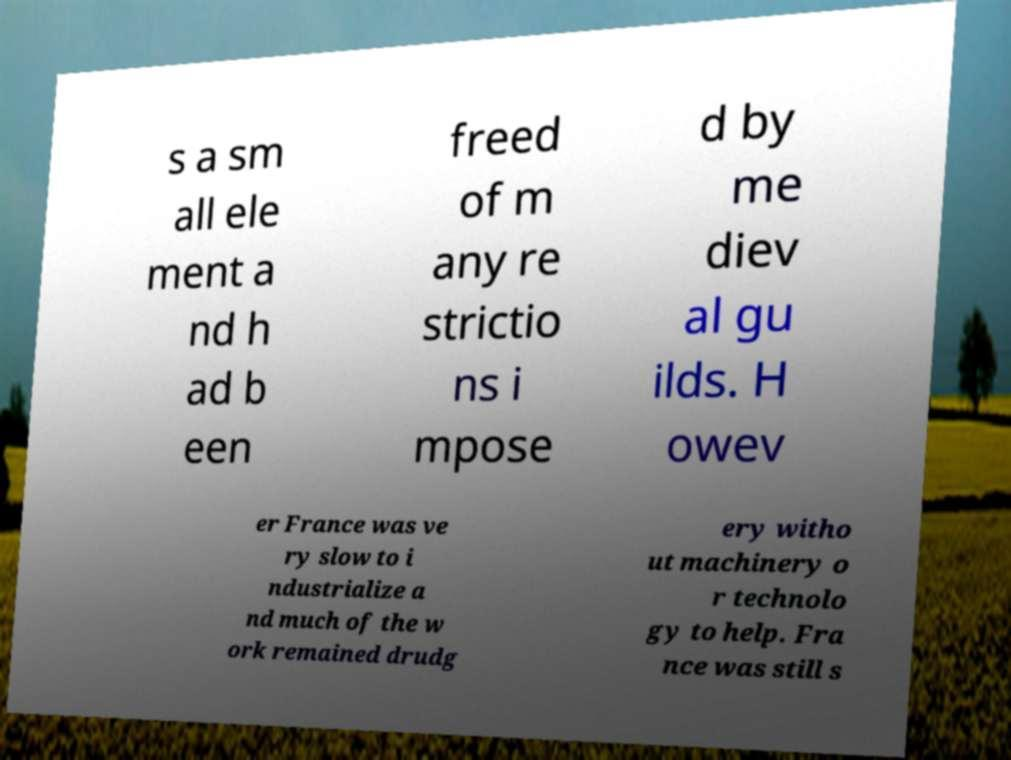Please read and relay the text visible in this image. What does it say? s a sm all ele ment a nd h ad b een freed of m any re strictio ns i mpose d by me diev al gu ilds. H owev er France was ve ry slow to i ndustrialize a nd much of the w ork remained drudg ery witho ut machinery o r technolo gy to help. Fra nce was still s 